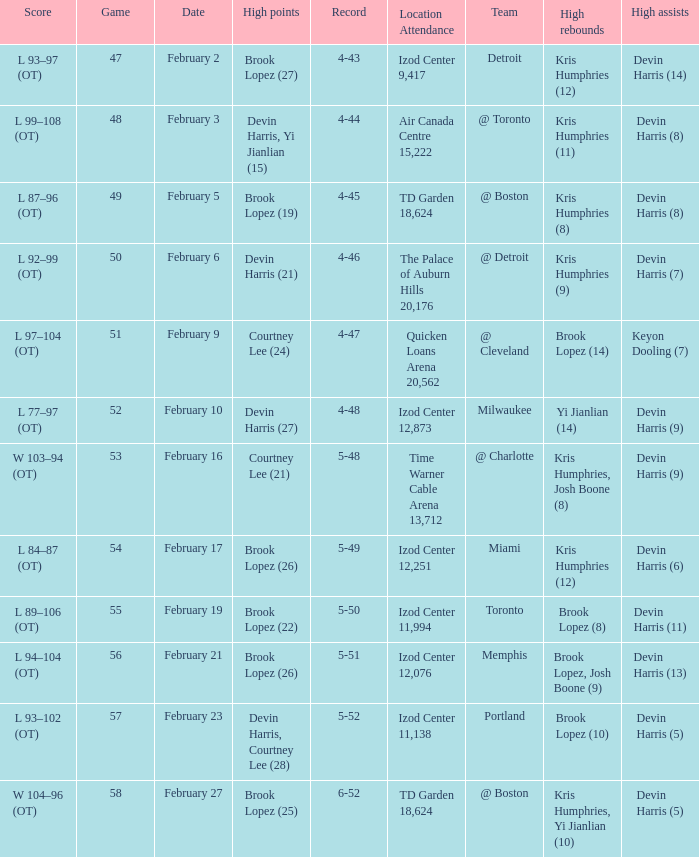Help me parse the entirety of this table. {'header': ['Score', 'Game', 'Date', 'High points', 'Record', 'Location Attendance', 'Team', 'High rebounds', 'High assists'], 'rows': [['L 93–97 (OT)', '47', 'February 2', 'Brook Lopez (27)', '4-43', 'Izod Center 9,417', 'Detroit', 'Kris Humphries (12)', 'Devin Harris (14)'], ['L 99–108 (OT)', '48', 'February 3', 'Devin Harris, Yi Jianlian (15)', '4-44', 'Air Canada Centre 15,222', '@ Toronto', 'Kris Humphries (11)', 'Devin Harris (8)'], ['L 87–96 (OT)', '49', 'February 5', 'Brook Lopez (19)', '4-45', 'TD Garden 18,624', '@ Boston', 'Kris Humphries (8)', 'Devin Harris (8)'], ['L 92–99 (OT)', '50', 'February 6', 'Devin Harris (21)', '4-46', 'The Palace of Auburn Hills 20,176', '@ Detroit', 'Kris Humphries (9)', 'Devin Harris (7)'], ['L 97–104 (OT)', '51', 'February 9', 'Courtney Lee (24)', '4-47', 'Quicken Loans Arena 20,562', '@ Cleveland', 'Brook Lopez (14)', 'Keyon Dooling (7)'], ['L 77–97 (OT)', '52', 'February 10', 'Devin Harris (27)', '4-48', 'Izod Center 12,873', 'Milwaukee', 'Yi Jianlian (14)', 'Devin Harris (9)'], ['W 103–94 (OT)', '53', 'February 16', 'Courtney Lee (21)', '5-48', 'Time Warner Cable Arena 13,712', '@ Charlotte', 'Kris Humphries, Josh Boone (8)', 'Devin Harris (9)'], ['L 84–87 (OT)', '54', 'February 17', 'Brook Lopez (26)', '5-49', 'Izod Center 12,251', 'Miami', 'Kris Humphries (12)', 'Devin Harris (6)'], ['L 89–106 (OT)', '55', 'February 19', 'Brook Lopez (22)', '5-50', 'Izod Center 11,994', 'Toronto', 'Brook Lopez (8)', 'Devin Harris (11)'], ['L 94–104 (OT)', '56', 'February 21', 'Brook Lopez (26)', '5-51', 'Izod Center 12,076', 'Memphis', 'Brook Lopez, Josh Boone (9)', 'Devin Harris (13)'], ['L 93–102 (OT)', '57', 'February 23', 'Devin Harris, Courtney Lee (28)', '5-52', 'Izod Center 11,138', 'Portland', 'Brook Lopez (10)', 'Devin Harris (5)'], ['W 104–96 (OT)', '58', 'February 27', 'Brook Lopez (25)', '6-52', 'TD Garden 18,624', '@ Boston', 'Kris Humphries, Yi Jianlian (10)', 'Devin Harris (5)']]} What was the score of the game in which Brook Lopez (8) did the high rebounds? L 89–106 (OT). 